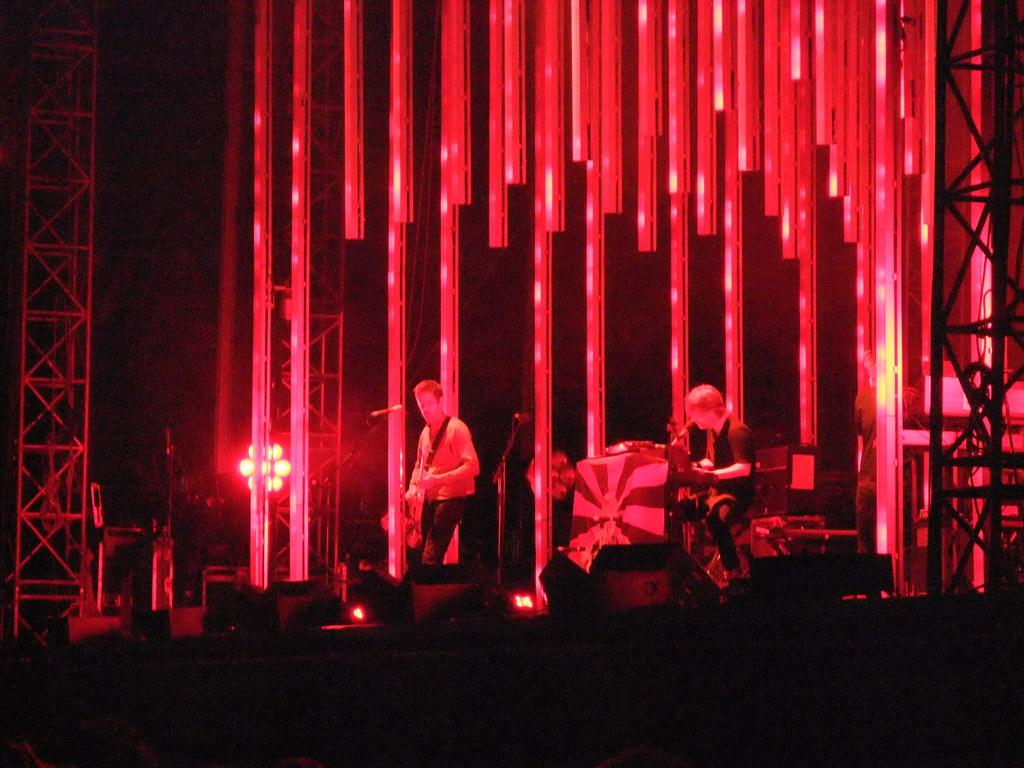How many people are in the image? There are two people in the image. What are the people doing in the image? Both people are playing guitars. What can be seen in the image that might be used for amplifying sound? There are speakers in the image. What type of objects are present in the image that might be used for hanging or displaying items? There are frames in the image. What type of structural elements are visible in the image? There are iron rods in the image. How would you describe the lighting conditions in the image? The background of the image is dark, but there are lights visible. What type of bedroom furniture can be seen in the image? There is no bedroom furniture present in the image. What type of family activity is depicted in the image? The image does not depict a family activity; it shows two people playing guitars. What type of food is being served in the image? There is no food visible in the image; the image features people playing guitars and various objects. 